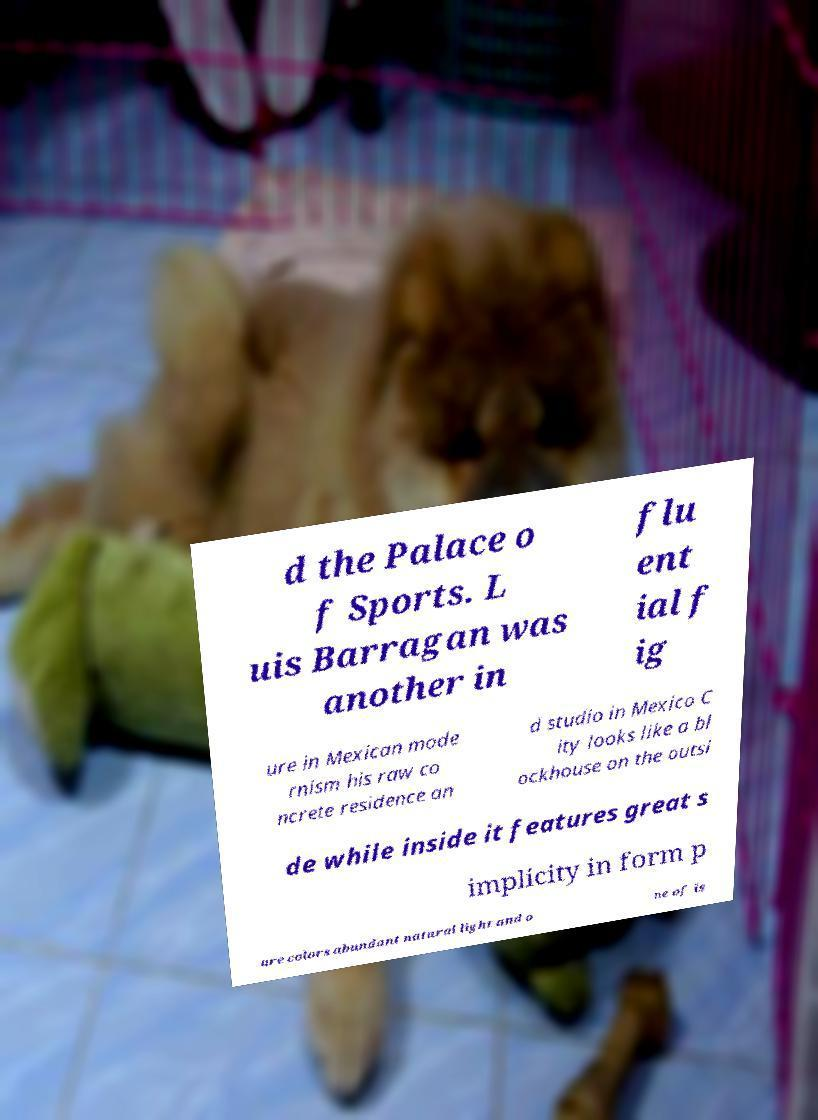Please identify and transcribe the text found in this image. d the Palace o f Sports. L uis Barragan was another in flu ent ial f ig ure in Mexican mode rnism his raw co ncrete residence an d studio in Mexico C ity looks like a bl ockhouse on the outsi de while inside it features great s implicity in form p ure colors abundant natural light and o ne of is 